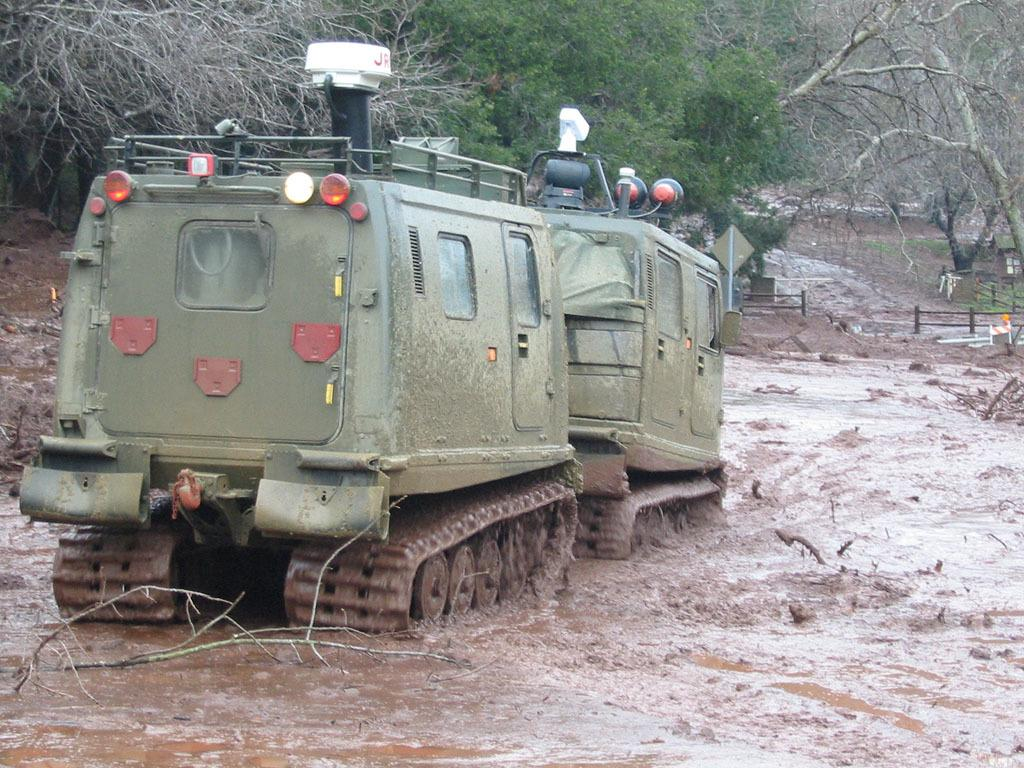What can be seen on the left side of the image? There are two vehicles on the left side of the image. What is the condition of the ground where the vehicles are located? The vehicles are on wet mud. What type of natural environment is visible in the background of the image? There are trees in the background of the image. What type of barrier can be seen in the background of the image? There is a fence on the ground in the background of the image. What type of square can be seen in the image? There is no square present in the image. What type of gate can be seen in the image? There is no gate present in the image. 